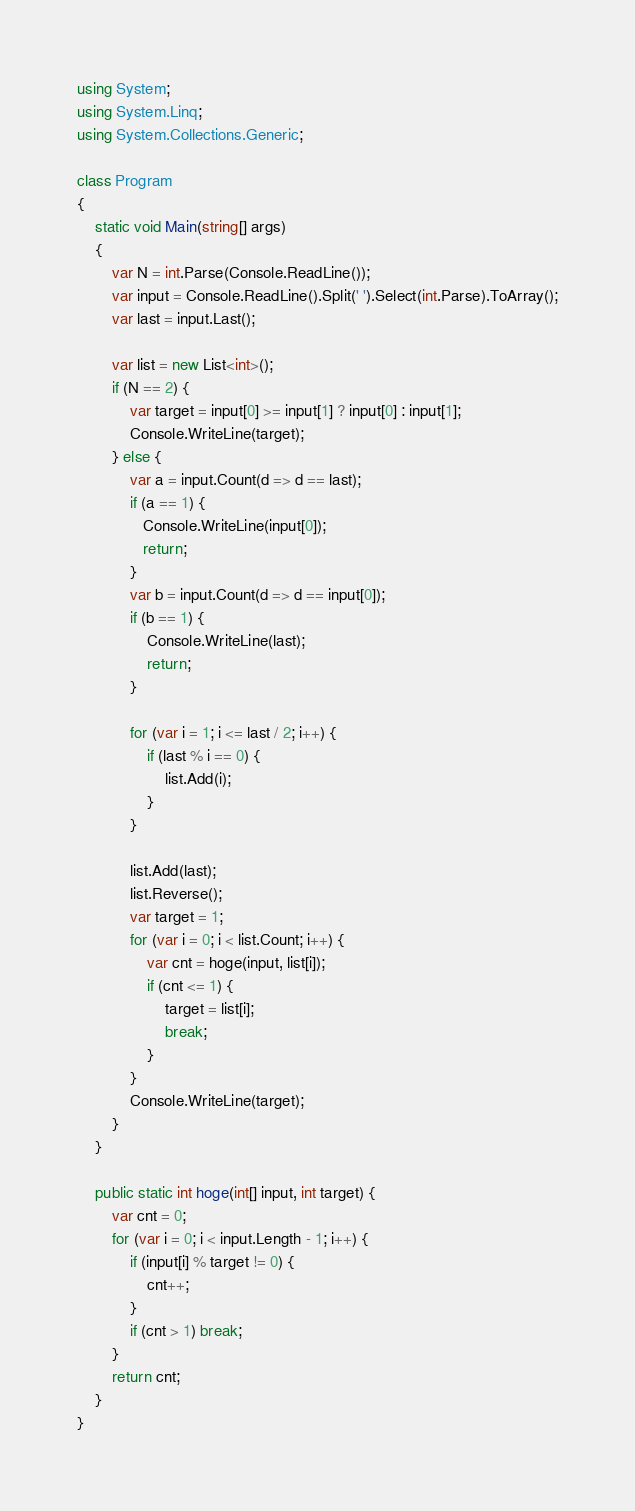Convert code to text. <code><loc_0><loc_0><loc_500><loc_500><_C#_>using System;
using System.Linq;
using System.Collections.Generic;

class Program
{
    static void Main(string[] args)
    {
        var N = int.Parse(Console.ReadLine());
        var input = Console.ReadLine().Split(' ').Select(int.Parse).ToArray();
        var last = input.Last();
        
        var list = new List<int>();
        if (N == 2) {
            var target = input[0] >= input[1] ? input[0] : input[1];
            Console.WriteLine(target);
        } else {
            var a = input.Count(d => d == last);
            if (a == 1) {
               Console.WriteLine(input[0]); 
               return;
            }
            var b = input.Count(d => d == input[0]);
            if (b == 1) {
                Console.WriteLine(last);
                return;
            }
        
            for (var i = 1; i <= last / 2; i++) {
                if (last % i == 0) {
                    list.Add(i);
                }
            }
            
            list.Add(last);
            list.Reverse();
            var target = 1;
            for (var i = 0; i < list.Count; i++) {
                var cnt = hoge(input, list[i]);
                if (cnt <= 1) {
                    target = list[i];
                    break;
                }
            }            
            Console.WriteLine(target);
        }
    }
    
    public static int hoge(int[] input, int target) {
        var cnt = 0;
        for (var i = 0; i < input.Length - 1; i++) {
            if (input[i] % target != 0) {
                cnt++;
            }
            if (cnt > 1) break;
        }
        return cnt;
    }
}
</code> 